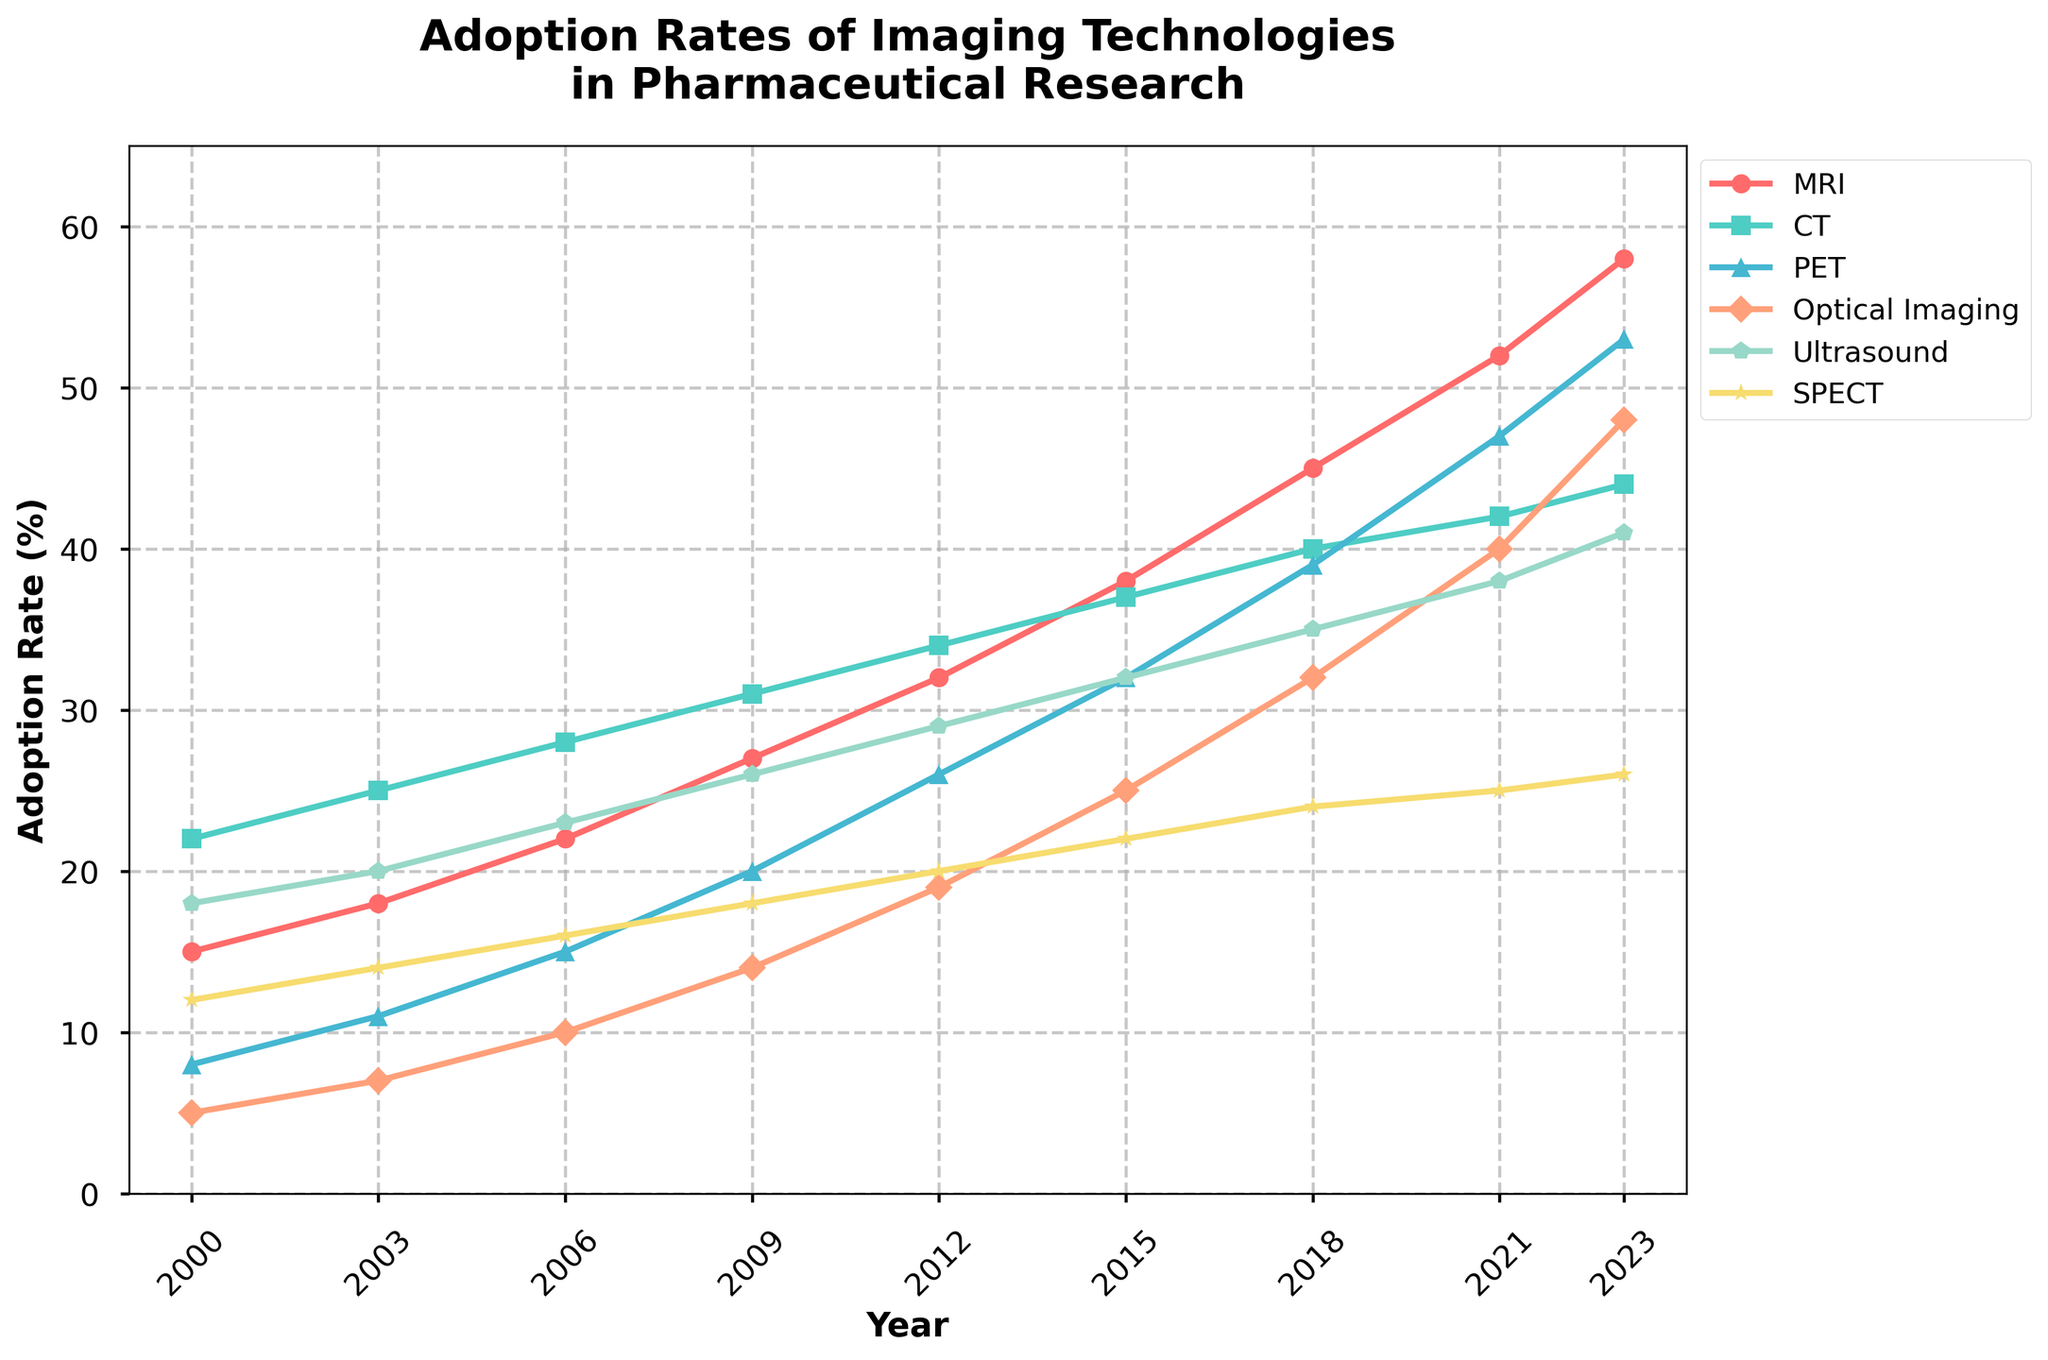What is the adoption rate of MRI in 2023? Look at the line representing MRI and find its point in 2023. The y-axis value at this point is the adoption rate of MRI.
Answer: 58 Which imaging technology had the highest adoption rate in 2023? Compare the y-axis values of all imaging technologies in 2023. The highest value corresponds to the technology with the highest adoption rate.
Answer: MRI In which year did PET surpass Ultrasound in adoption rate? Track the line representing PET and Ultrasound over the years. Find the year where the PET line is above the Ultrasound line.
Answer: 2015 How much did the adoption rate of CT increase from 2000 to 2023? Subtract the adoption rate of CT in 2000 from its adoption rate in 2023.
Answer: 22 What's the average adoption rate of Optical Imaging from 2000 to 2023? Sum the adoption rates of Optical Imaging for each year from 2000 to 2023, then divide by the number of years.
Answer: 22 Compare the adoption rates of Optical Imaging and SPECT in 2012. Which one is higher? Look at the adoption rates of Optical Imaging and SPECT in 2012 and compare their y-axis values.
Answer: Optical Imaging Which technology had a consistent increase in adoption rate from 2000 to 2023? Check each technology’s trend line. The one that consistently increases without any drop is the answer.
Answer: MRI What was the adoption rate difference between MRI and PET in 2021? Subtract the adoption rate of PET in 2021 from that of MRI in 2021.
Answer: 5 Among all technologies, which had the smallest increase in adoption rate from 2000 to 2023? Calculate the adoption rate increase (2023 rate - 2000 rate) for each technology and find the smallest difference.
Answer: SPECT What's the total adoption rate of all technologies in 2015? Sum the adoption rates of all technologies in 2015.
Answer: 186 